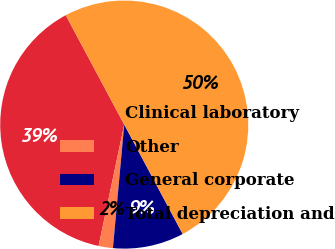<chart> <loc_0><loc_0><loc_500><loc_500><pie_chart><fcel>Clinical laboratory<fcel>Other<fcel>General corporate<fcel>Total depreciation and<nl><fcel>38.87%<fcel>1.86%<fcel>9.26%<fcel>50.0%<nl></chart> 